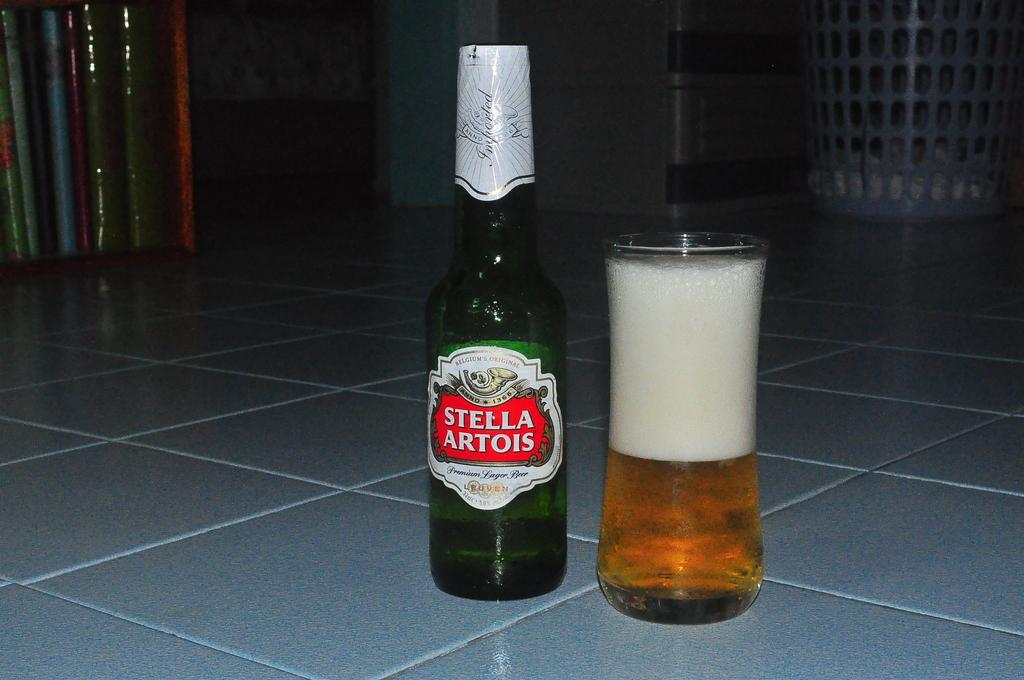What type of beverage is present in the image? There is beer in the image, as seen in both the beer bottle and the cup. Can you describe the containers holding the beer? There is a beer bottle and a cup with beer in the image. What scent can be detected from the dinosaurs in the image? There are no dinosaurs present in the image, so there is no scent to detect. 